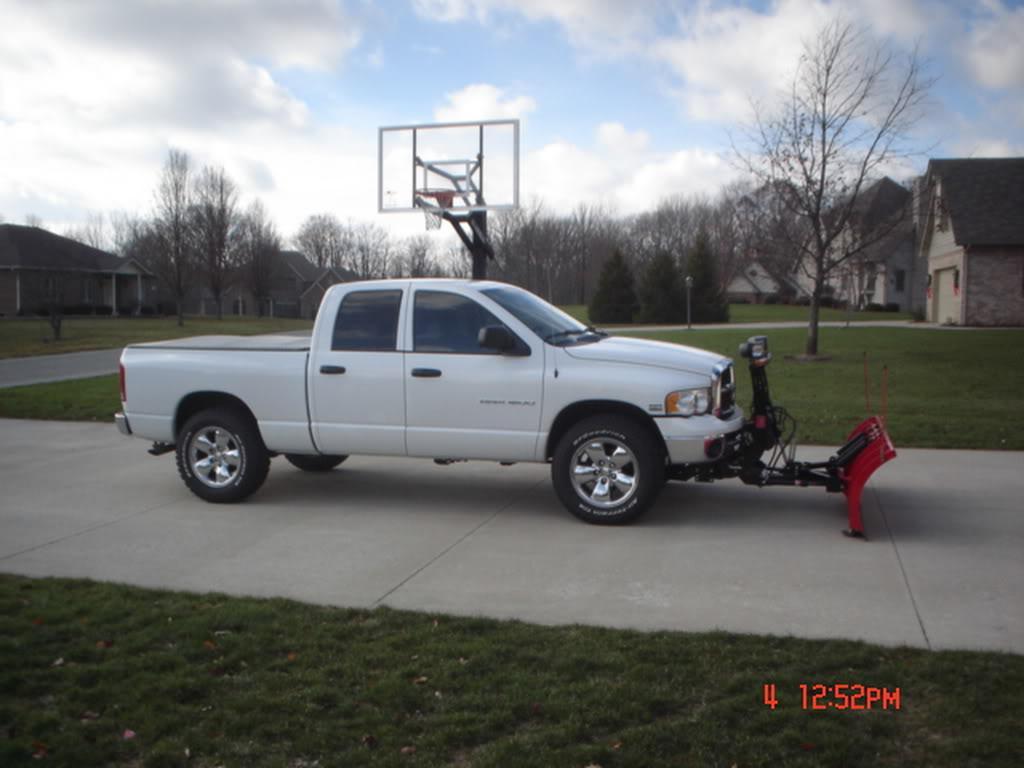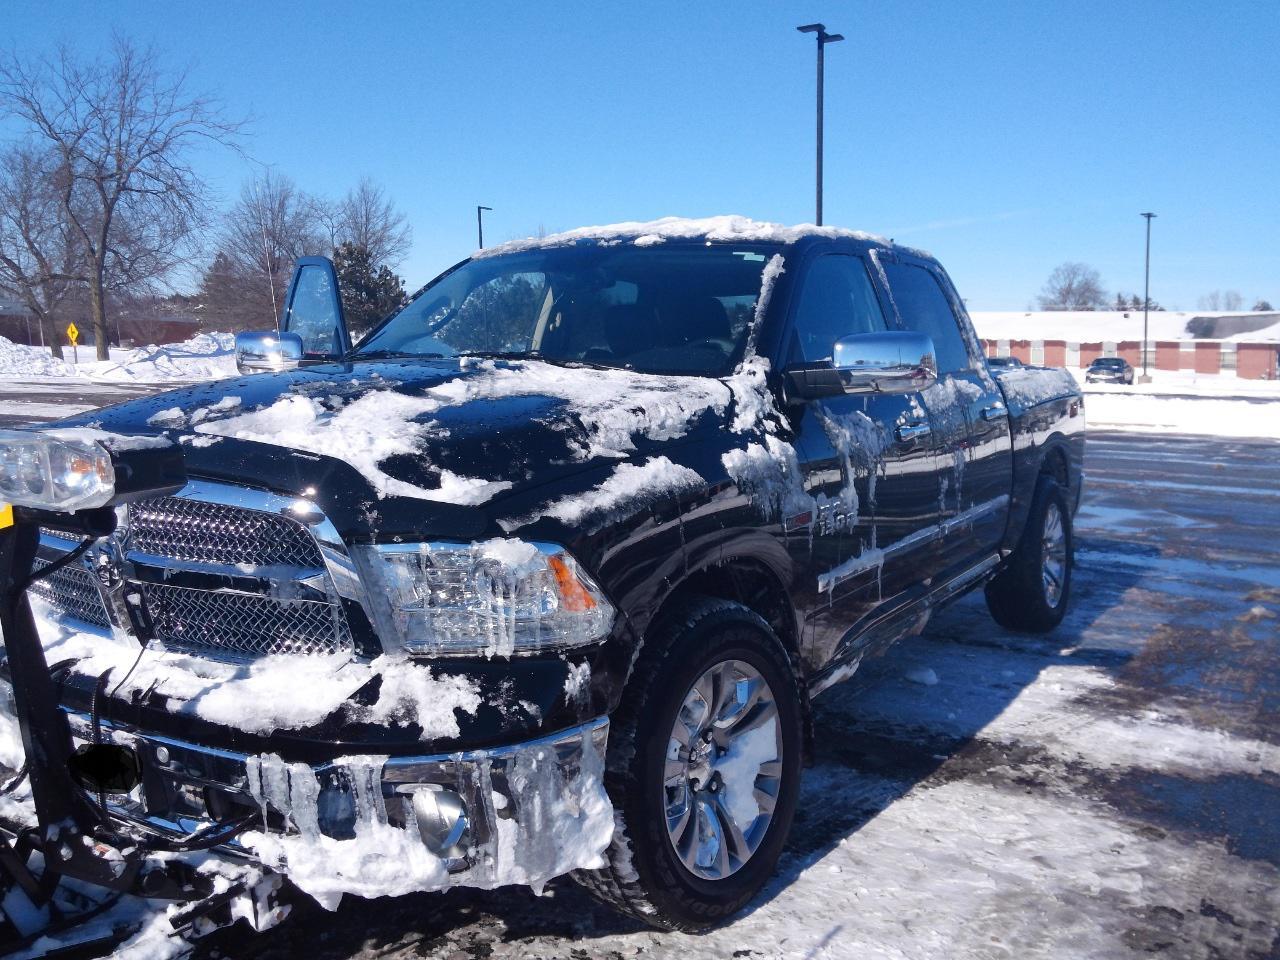The first image is the image on the left, the second image is the image on the right. Analyze the images presented: Is the assertion "The left and right image contains the same number of black trucks with a plow." valid? Answer yes or no. No. The first image is the image on the left, the second image is the image on the right. Examine the images to the left and right. Is the description "One image features a rightward-facing truck with a plow on its front, parked on dry pavement with no snow in sight." accurate? Answer yes or no. Yes. 